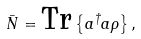Convert formula to latex. <formula><loc_0><loc_0><loc_500><loc_500>\bar { N } = \text {Tr} \left \{ a ^ { \dagger } a \rho \right \} ,</formula> 